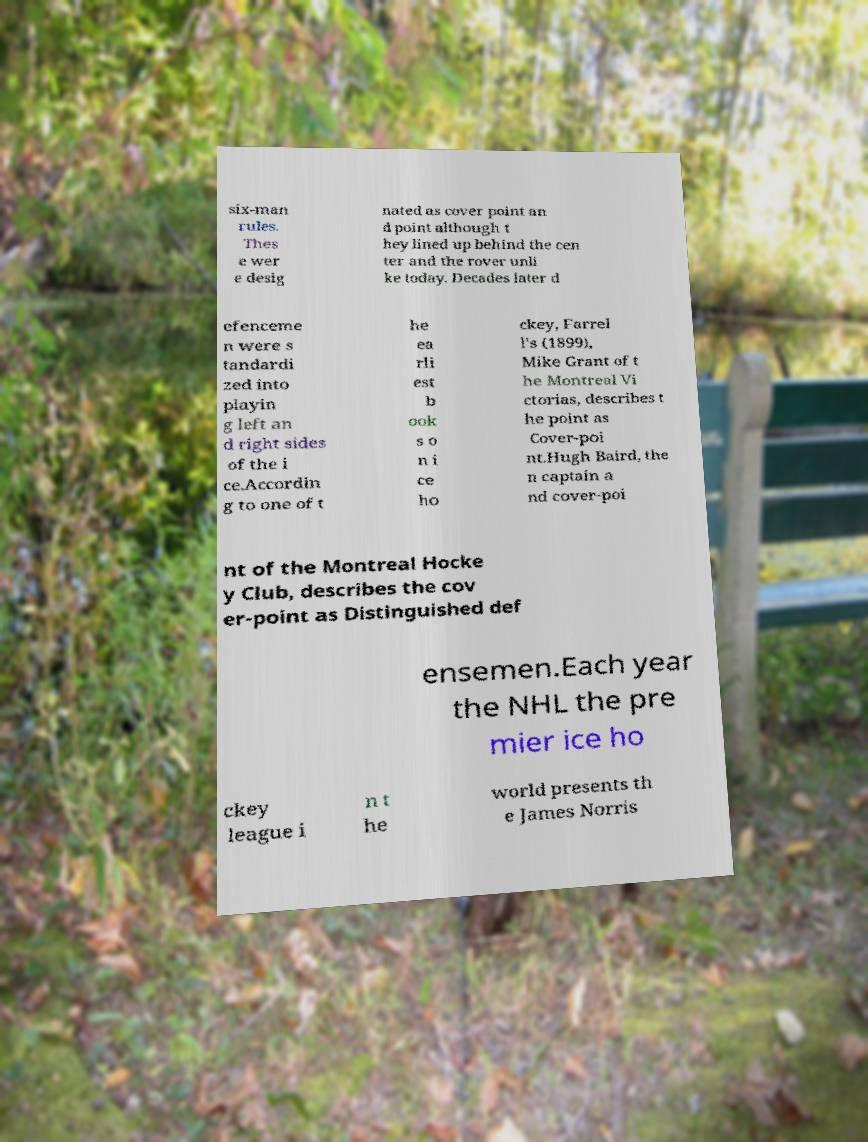Can you read and provide the text displayed in the image?This photo seems to have some interesting text. Can you extract and type it out for me? six-man rules. Thes e wer e desig nated as cover point an d point although t hey lined up behind the cen ter and the rover unli ke today. Decades later d efenceme n were s tandardi zed into playin g left an d right sides of the i ce.Accordin g to one of t he ea rli est b ook s o n i ce ho ckey, Farrel l's (1899), Mike Grant of t he Montreal Vi ctorias, describes t he point as Cover-poi nt.Hugh Baird, the n captain a nd cover-poi nt of the Montreal Hocke y Club, describes the cov er-point as Distinguished def ensemen.Each year the NHL the pre mier ice ho ckey league i n t he world presents th e James Norris 